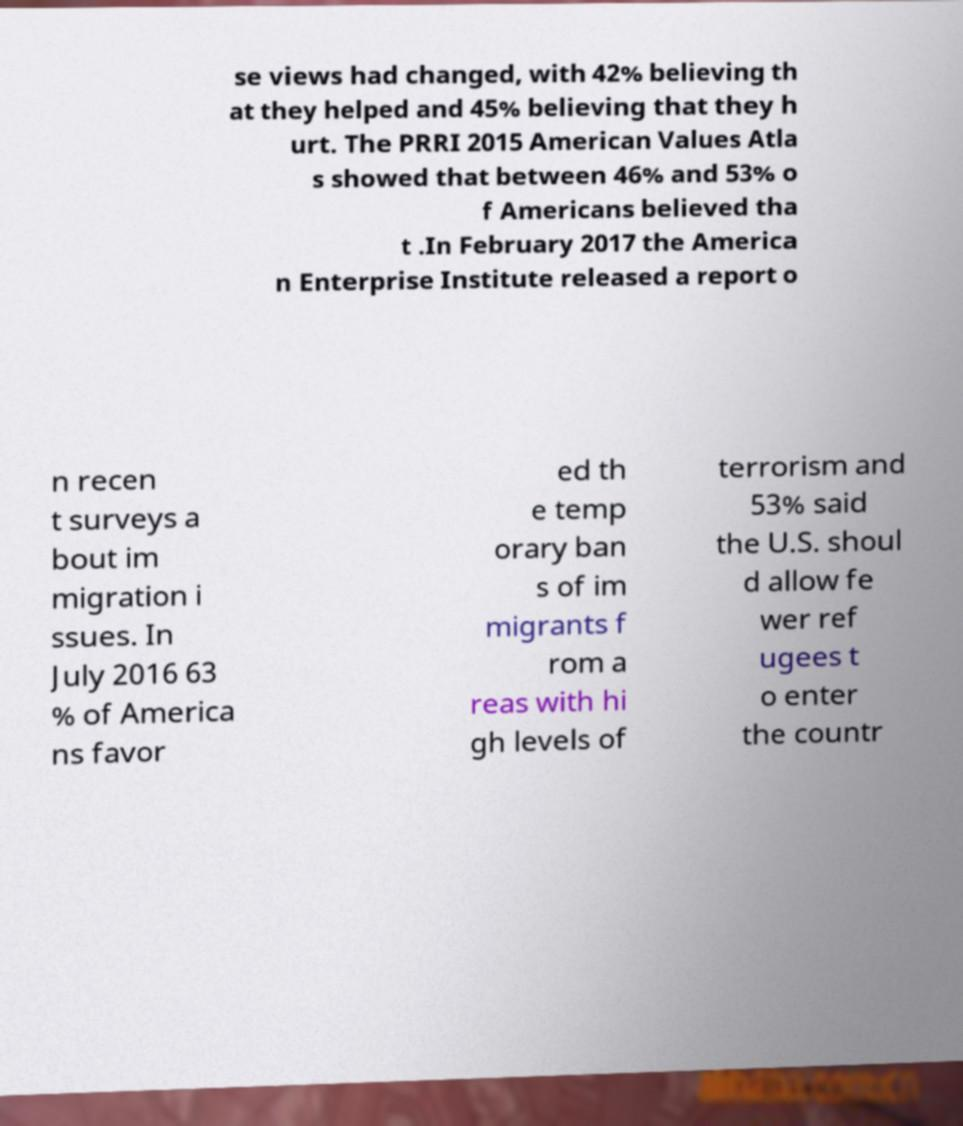What messages or text are displayed in this image? I need them in a readable, typed format. se views had changed, with 42% believing th at they helped and 45% believing that they h urt. The PRRI 2015 American Values Atla s showed that between 46% and 53% o f Americans believed tha t .In February 2017 the America n Enterprise Institute released a report o n recen t surveys a bout im migration i ssues. In July 2016 63 % of America ns favor ed th e temp orary ban s of im migrants f rom a reas with hi gh levels of terrorism and 53% said the U.S. shoul d allow fe wer ref ugees t o enter the countr 